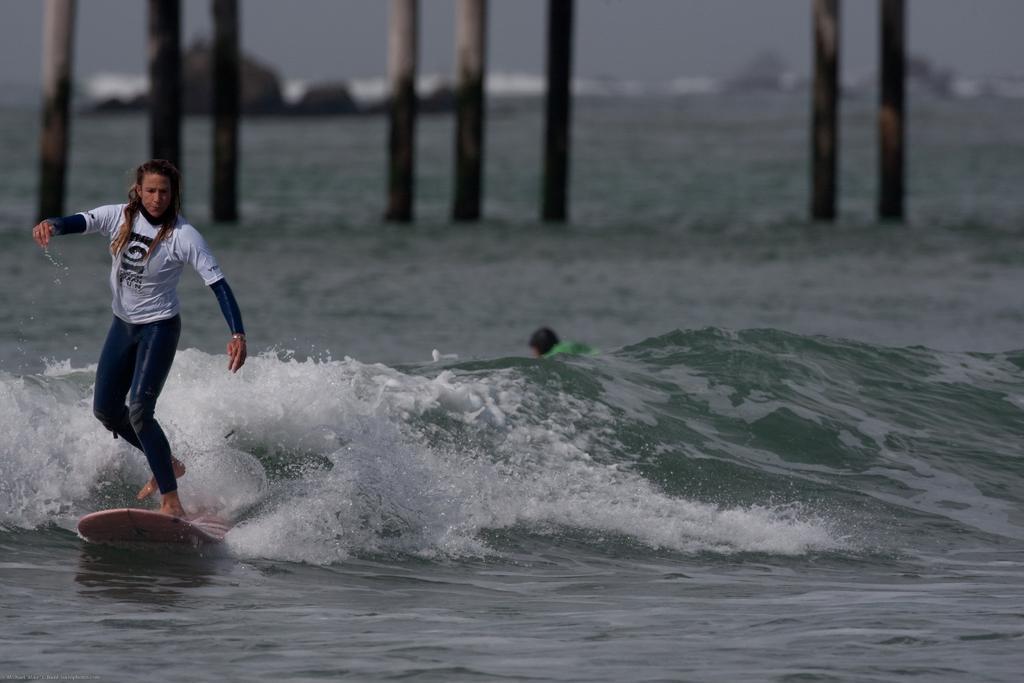Please provide a concise description of this image. In this image there is a girl standing,on a surfing board and surfing on a sea, in the background there are poles and it is blurred. 